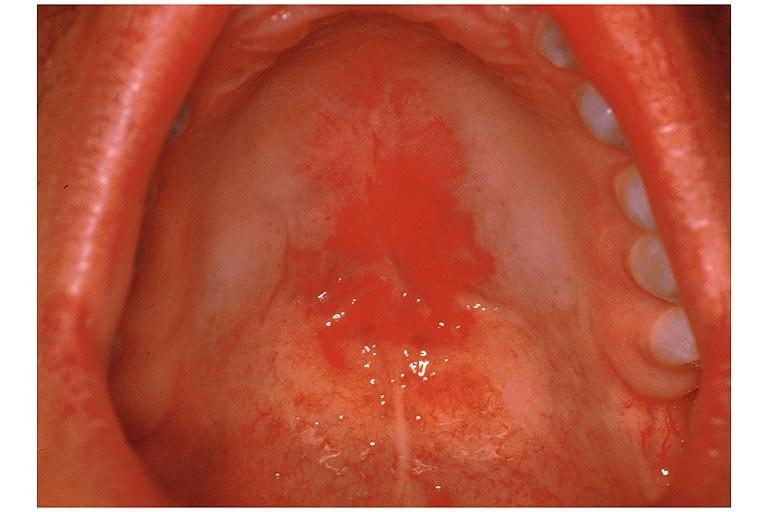s oral present?
Answer the question using a single word or phrase. Yes 